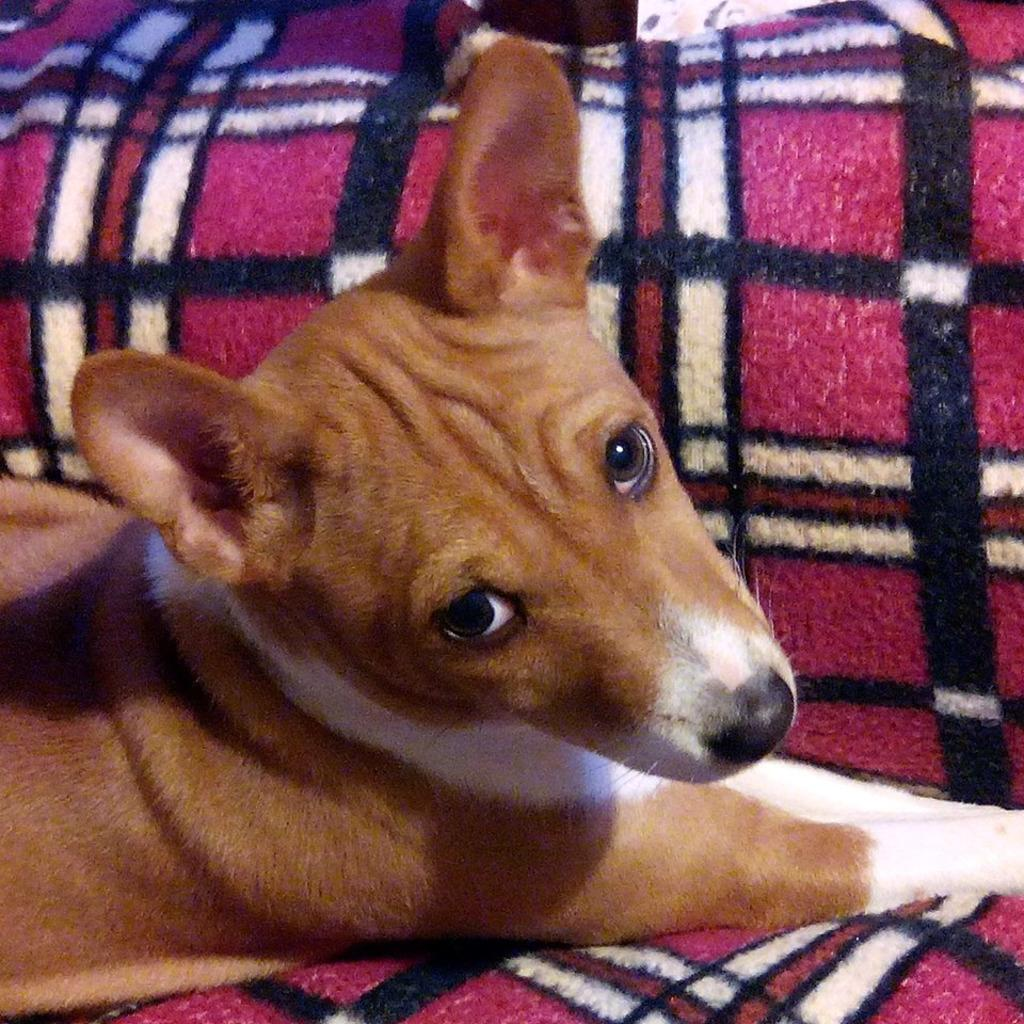What type of animal is present in the image? There is a dog in the image. Where is the dog located in the image? The dog is sitting on a cloth. Can you describe the stranger walking through the bushes in the image? There is no stranger or bushes present in the image; it only features a dog sitting on a cloth. 